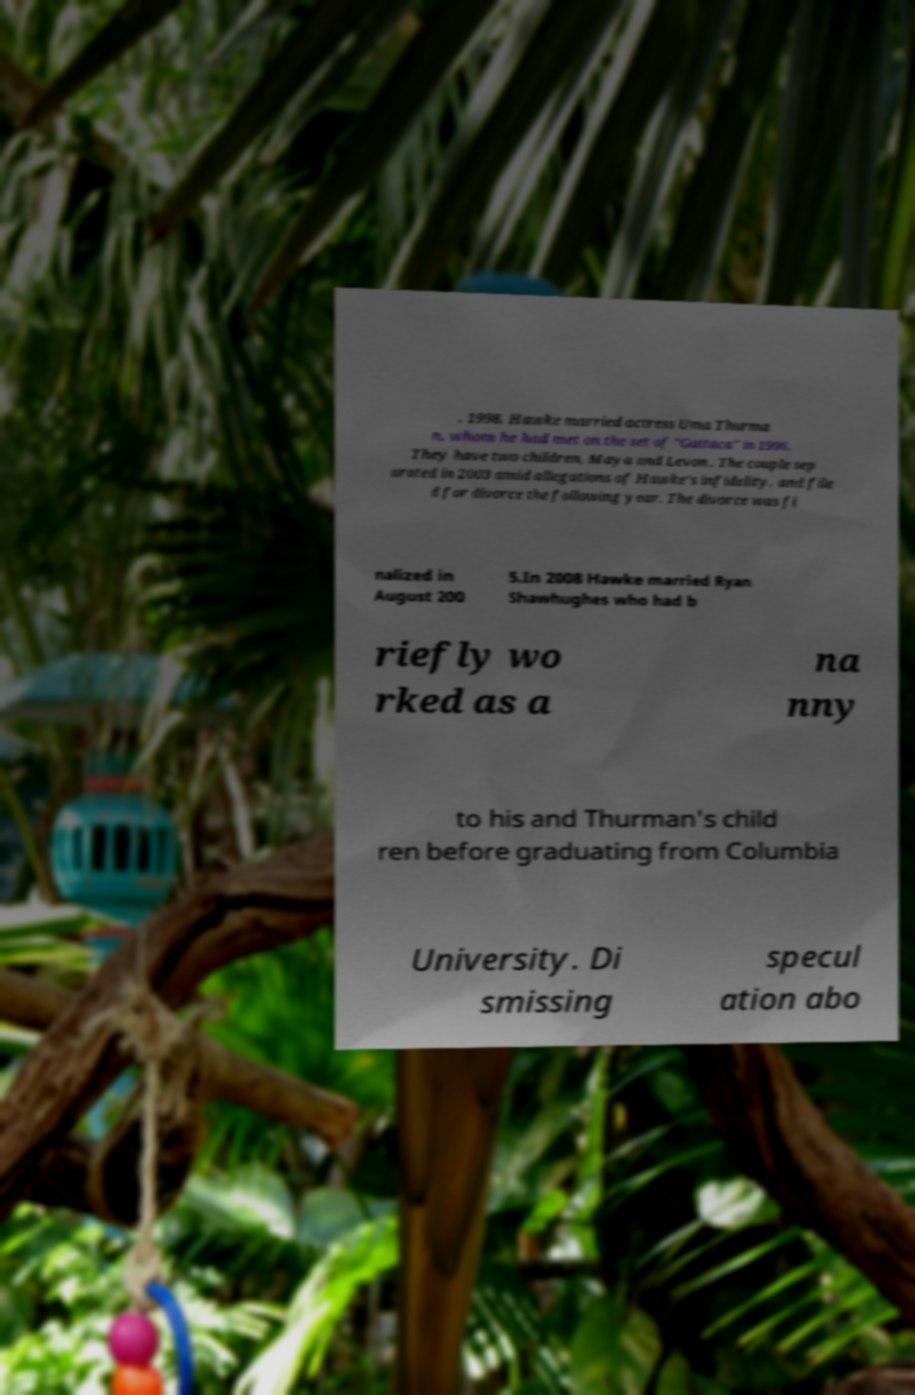Could you assist in decoding the text presented in this image and type it out clearly? , 1998, Hawke married actress Uma Thurma n, whom he had met on the set of "Gattaca" in 1996. They have two children, Maya and Levon . The couple sep arated in 2003 amid allegations of Hawke's infidelity, and file d for divorce the following year. The divorce was fi nalized in August 200 5.In 2008 Hawke married Ryan Shawhughes who had b riefly wo rked as a na nny to his and Thurman's child ren before graduating from Columbia University. Di smissing specul ation abo 